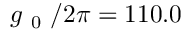Convert formula to latex. <formula><loc_0><loc_0><loc_500><loc_500>g _ { 0 } / 2 \pi = 1 1 0 . 0</formula> 